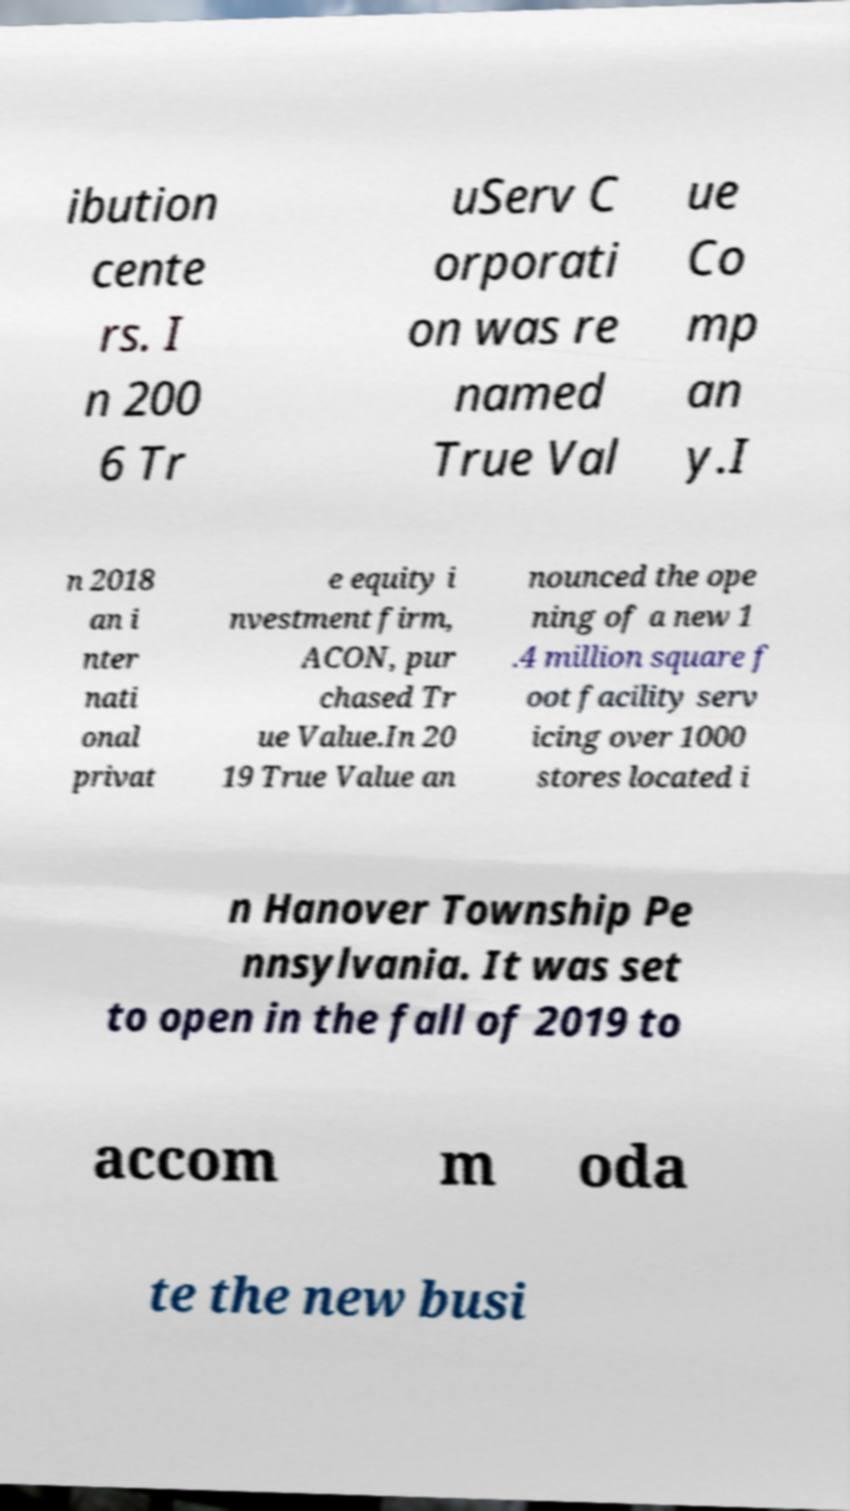What messages or text are displayed in this image? I need them in a readable, typed format. ibution cente rs. I n 200 6 Tr uServ C orporati on was re named True Val ue Co mp an y.I n 2018 an i nter nati onal privat e equity i nvestment firm, ACON, pur chased Tr ue Value.In 20 19 True Value an nounced the ope ning of a new 1 .4 million square f oot facility serv icing over 1000 stores located i n Hanover Township Pe nnsylvania. It was set to open in the fall of 2019 to accom m oda te the new busi 